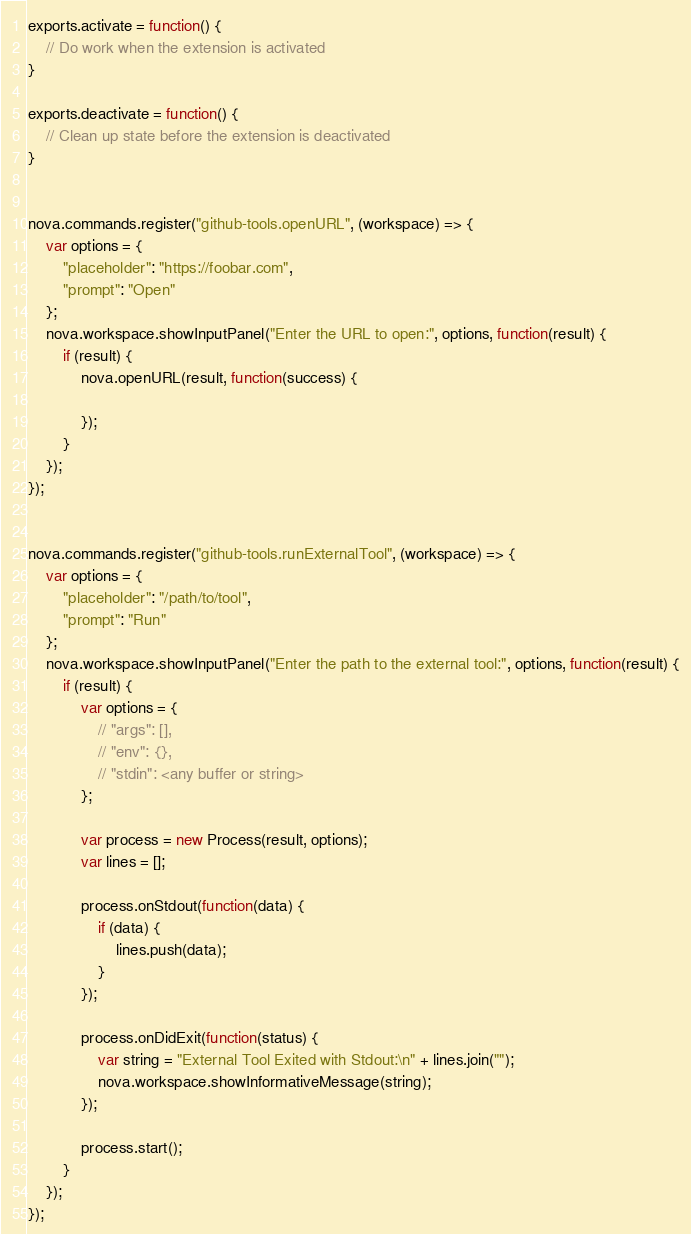<code> <loc_0><loc_0><loc_500><loc_500><_JavaScript_>
exports.activate = function() {
    // Do work when the extension is activated
}

exports.deactivate = function() {
    // Clean up state before the extension is deactivated
}


nova.commands.register("github-tools.openURL", (workspace) => {
    var options = {
        "placeholder": "https://foobar.com",
        "prompt": "Open"
    };
    nova.workspace.showInputPanel("Enter the URL to open:", options, function(result) {
        if (result) {
            nova.openURL(result, function(success) {
                
            });
        }
    });
});


nova.commands.register("github-tools.runExternalTool", (workspace) => {
    var options = {
        "placeholder": "/path/to/tool",
        "prompt": "Run"
    };
    nova.workspace.showInputPanel("Enter the path to the external tool:", options, function(result) {
        if (result) {
            var options = {
                // "args": [],
                // "env": {},
                // "stdin": <any buffer or string>
            };
            
            var process = new Process(result, options);
            var lines = [];
            
            process.onStdout(function(data) {
                if (data) {
                    lines.push(data);
                }
            });
            
            process.onDidExit(function(status) {
                var string = "External Tool Exited with Stdout:\n" + lines.join("");
                nova.workspace.showInformativeMessage(string);
            });
            
            process.start();
        }
    });
});

</code> 